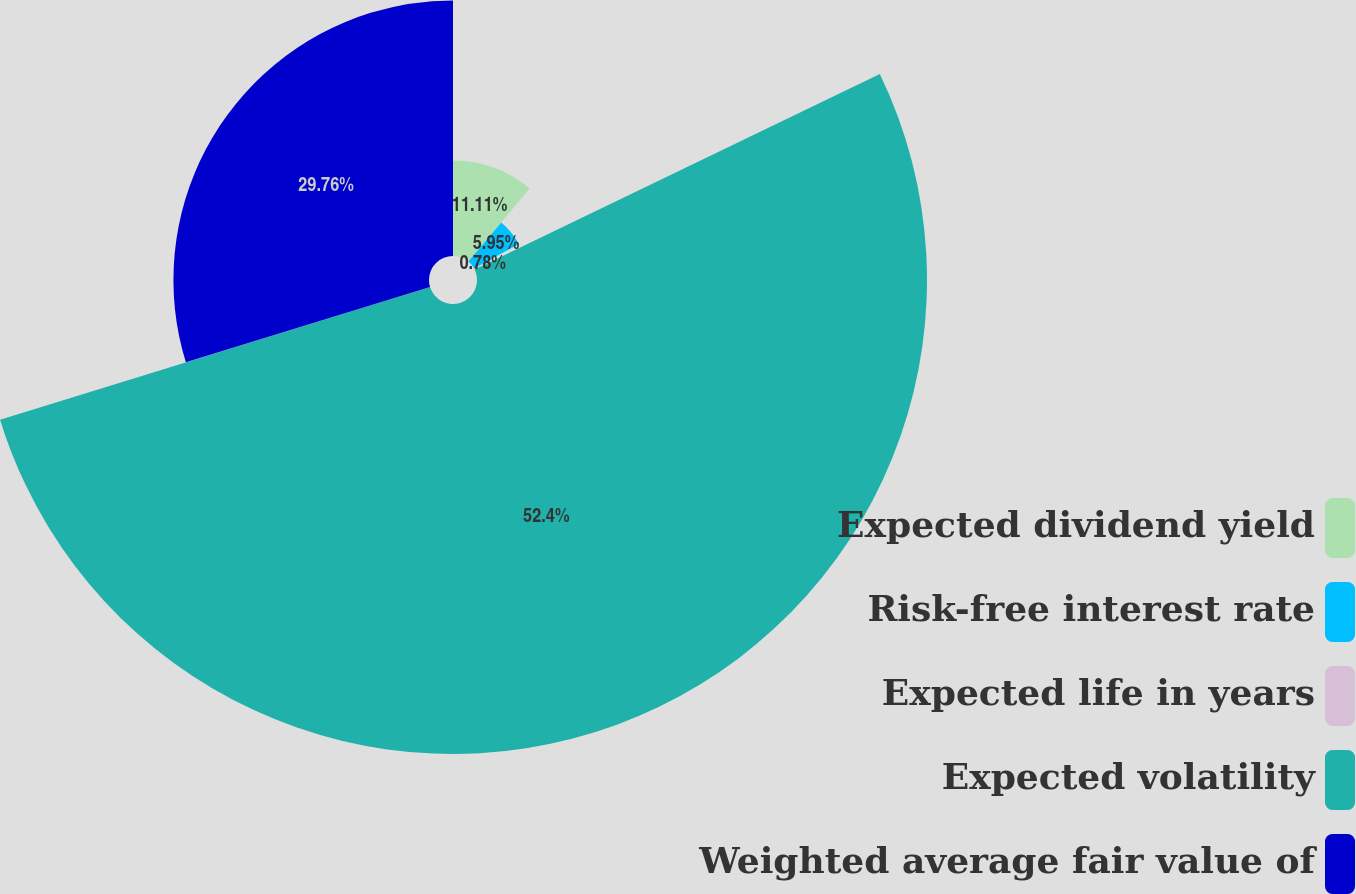<chart> <loc_0><loc_0><loc_500><loc_500><pie_chart><fcel>Expected dividend yield<fcel>Risk-free interest rate<fcel>Expected life in years<fcel>Expected volatility<fcel>Weighted average fair value of<nl><fcel>11.11%<fcel>5.95%<fcel>0.78%<fcel>52.4%<fcel>29.76%<nl></chart> 